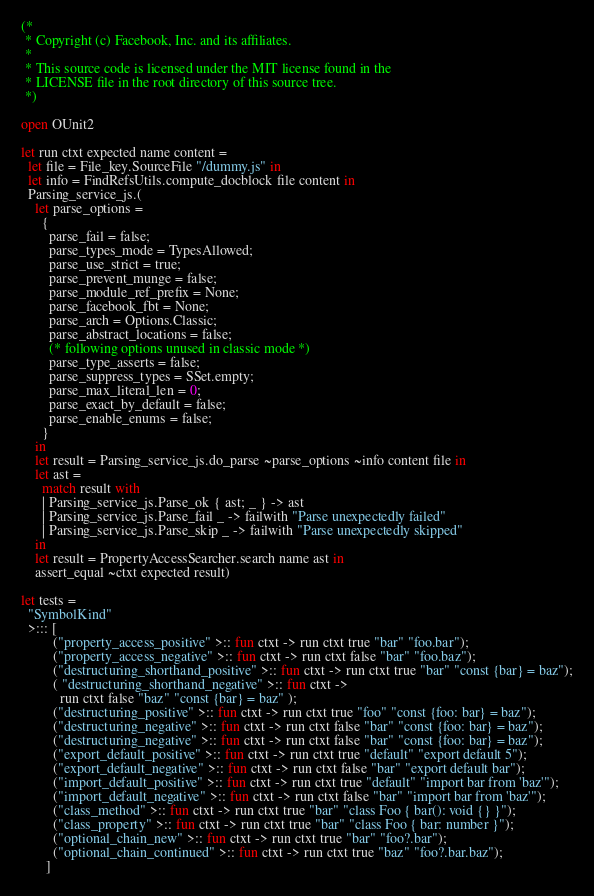Convert code to text. <code><loc_0><loc_0><loc_500><loc_500><_OCaml_>(*
 * Copyright (c) Facebook, Inc. and its affiliates.
 *
 * This source code is licensed under the MIT license found in the
 * LICENSE file in the root directory of this source tree.
 *)

open OUnit2

let run ctxt expected name content =
  let file = File_key.SourceFile "/dummy.js" in
  let info = FindRefsUtils.compute_docblock file content in
  Parsing_service_js.(
    let parse_options =
      {
        parse_fail = false;
        parse_types_mode = TypesAllowed;
        parse_use_strict = true;
        parse_prevent_munge = false;
        parse_module_ref_prefix = None;
        parse_facebook_fbt = None;
        parse_arch = Options.Classic;
        parse_abstract_locations = false;
        (* following options unused in classic mode *)
        parse_type_asserts = false;
        parse_suppress_types = SSet.empty;
        parse_max_literal_len = 0;
        parse_exact_by_default = false;
        parse_enable_enums = false;
      }
    in
    let result = Parsing_service_js.do_parse ~parse_options ~info content file in
    let ast =
      match result with
      | Parsing_service_js.Parse_ok { ast; _ } -> ast
      | Parsing_service_js.Parse_fail _ -> failwith "Parse unexpectedly failed"
      | Parsing_service_js.Parse_skip _ -> failwith "Parse unexpectedly skipped"
    in
    let result = PropertyAccessSearcher.search name ast in
    assert_equal ~ctxt expected result)

let tests =
  "SymbolKind"
  >::: [
         ("property_access_positive" >:: fun ctxt -> run ctxt true "bar" "foo.bar");
         ("property_access_negative" >:: fun ctxt -> run ctxt false "bar" "foo.baz");
         ("destructuring_shorthand_positive" >:: fun ctxt -> run ctxt true "bar" "const {bar} = baz");
         ( "destructuring_shorthand_negative" >:: fun ctxt ->
           run ctxt false "baz" "const {bar} = baz" );
         ("destructuring_positive" >:: fun ctxt -> run ctxt true "foo" "const {foo: bar} = baz");
         ("destructuring_negative" >:: fun ctxt -> run ctxt false "bar" "const {foo: bar} = baz");
         ("destructuring_negative" >:: fun ctxt -> run ctxt false "bar" "const {foo: bar} = baz");
         ("export_default_positive" >:: fun ctxt -> run ctxt true "default" "export default 5");
         ("export_default_negative" >:: fun ctxt -> run ctxt false "bar" "export default bar");
         ("import_default_positive" >:: fun ctxt -> run ctxt true "default" "import bar from 'baz'");
         ("import_default_negative" >:: fun ctxt -> run ctxt false "bar" "import bar from 'baz'");
         ("class_method" >:: fun ctxt -> run ctxt true "bar" "class Foo { bar(): void {} }");
         ("class_property" >:: fun ctxt -> run ctxt true "bar" "class Foo { bar: number }");
         ("optional_chain_new" >:: fun ctxt -> run ctxt true "bar" "foo?.bar");
         ("optional_chain_continued" >:: fun ctxt -> run ctxt true "baz" "foo?.bar.baz");
       ]
</code> 